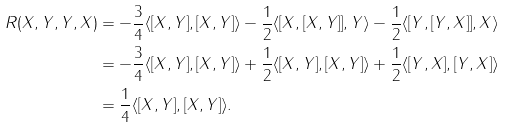<formula> <loc_0><loc_0><loc_500><loc_500>R ( X , Y , Y , X ) & = - \frac { 3 } { 4 } \langle [ X , Y ] , [ X , Y ] \rangle - \frac { 1 } { 2 } \langle [ X , [ X , Y ] ] , Y \rangle - \frac { 1 } { 2 } \langle [ Y , [ Y , X ] ] , X \rangle \\ & = - \frac { 3 } { 4 } \langle [ X , Y ] , [ X , Y ] \rangle + \frac { 1 } { 2 } \langle [ X , Y ] , [ X , Y ] \rangle + \frac { 1 } { 2 } \langle [ Y , X ] , [ Y , X ] \rangle \\ & = \frac { 1 } { 4 } \langle [ X , Y ] , [ X , Y ] \rangle .</formula> 